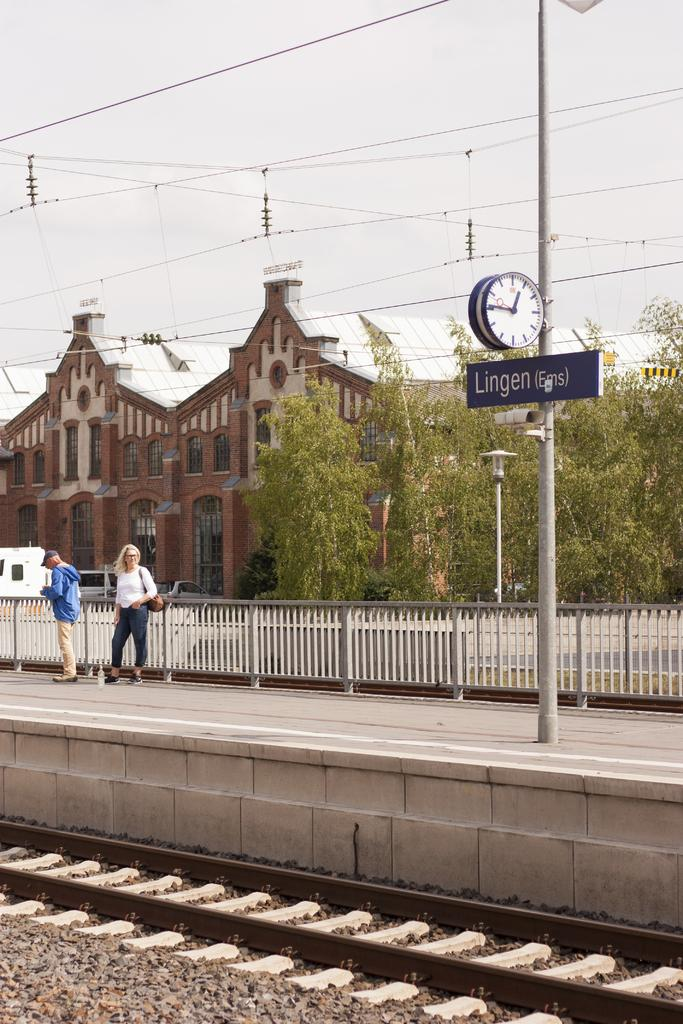<image>
Provide a brief description of the given image. A black sign under a clock reads Lingen. 